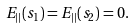<formula> <loc_0><loc_0><loc_500><loc_500>E _ { | | } ( s _ { 1 } ) = E _ { | | } ( s _ { 2 } ) = 0 .</formula> 